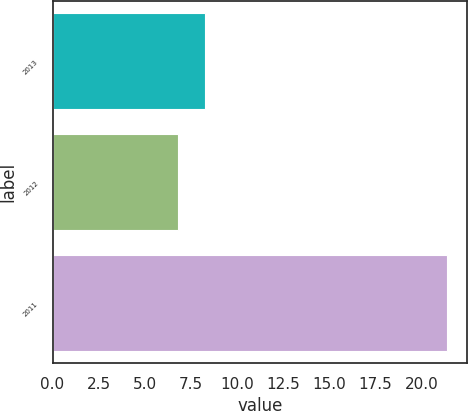Convert chart to OTSL. <chart><loc_0><loc_0><loc_500><loc_500><bar_chart><fcel>2013<fcel>2012<fcel>2011<nl><fcel>8.26<fcel>6.8<fcel>21.4<nl></chart> 